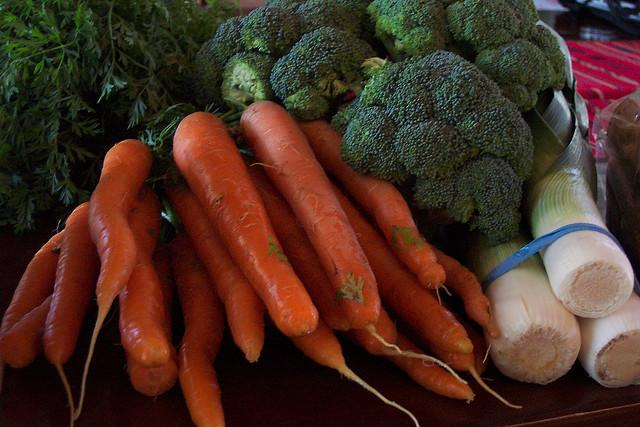What is a collective name given to the food options above?

Choices:
A) fruits
B) meat
C) nuts
D) veggies veggies 